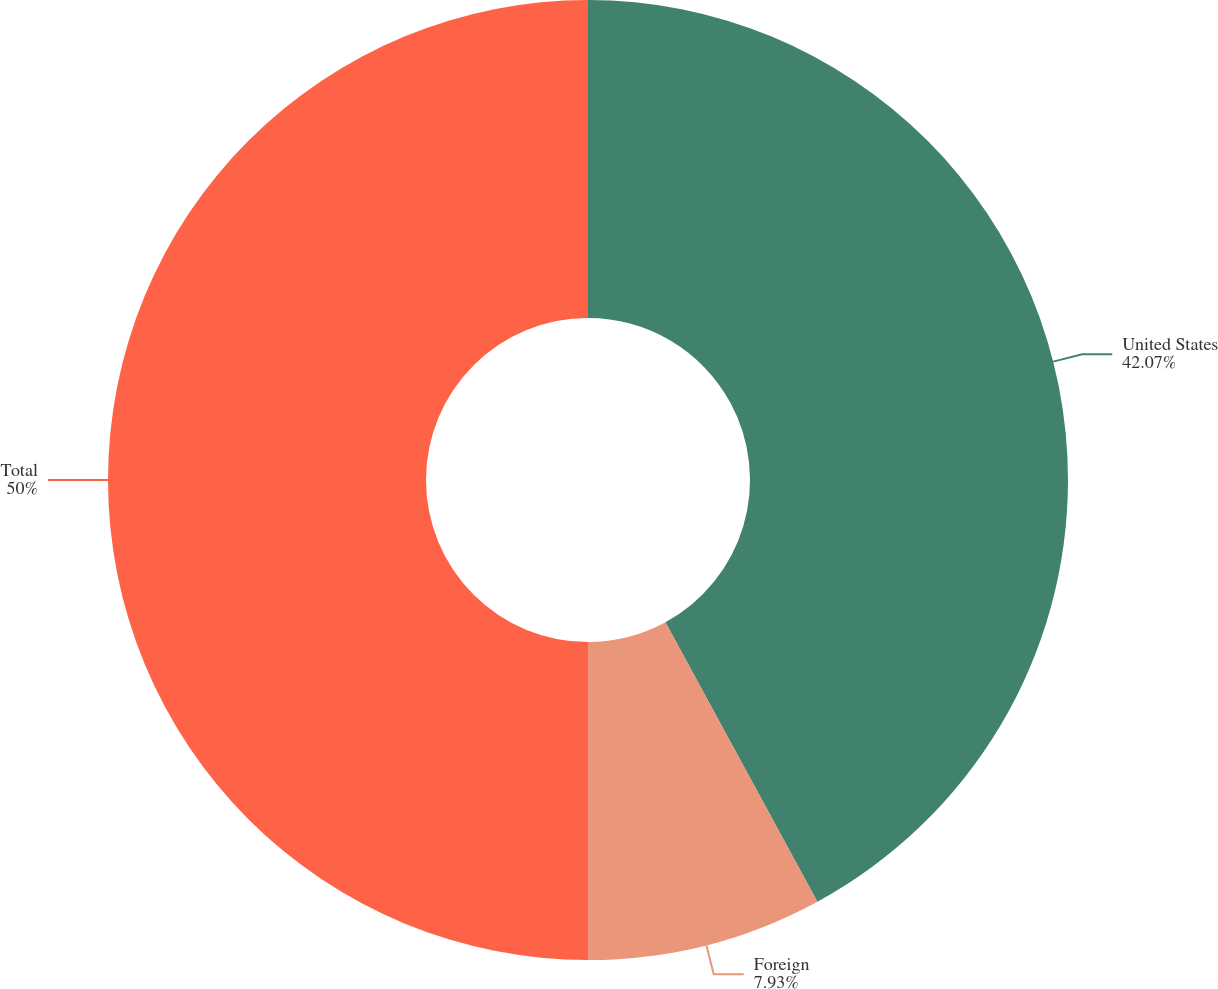Convert chart. <chart><loc_0><loc_0><loc_500><loc_500><pie_chart><fcel>United States<fcel>Foreign<fcel>Total<nl><fcel>42.07%<fcel>7.93%<fcel>50.0%<nl></chart> 